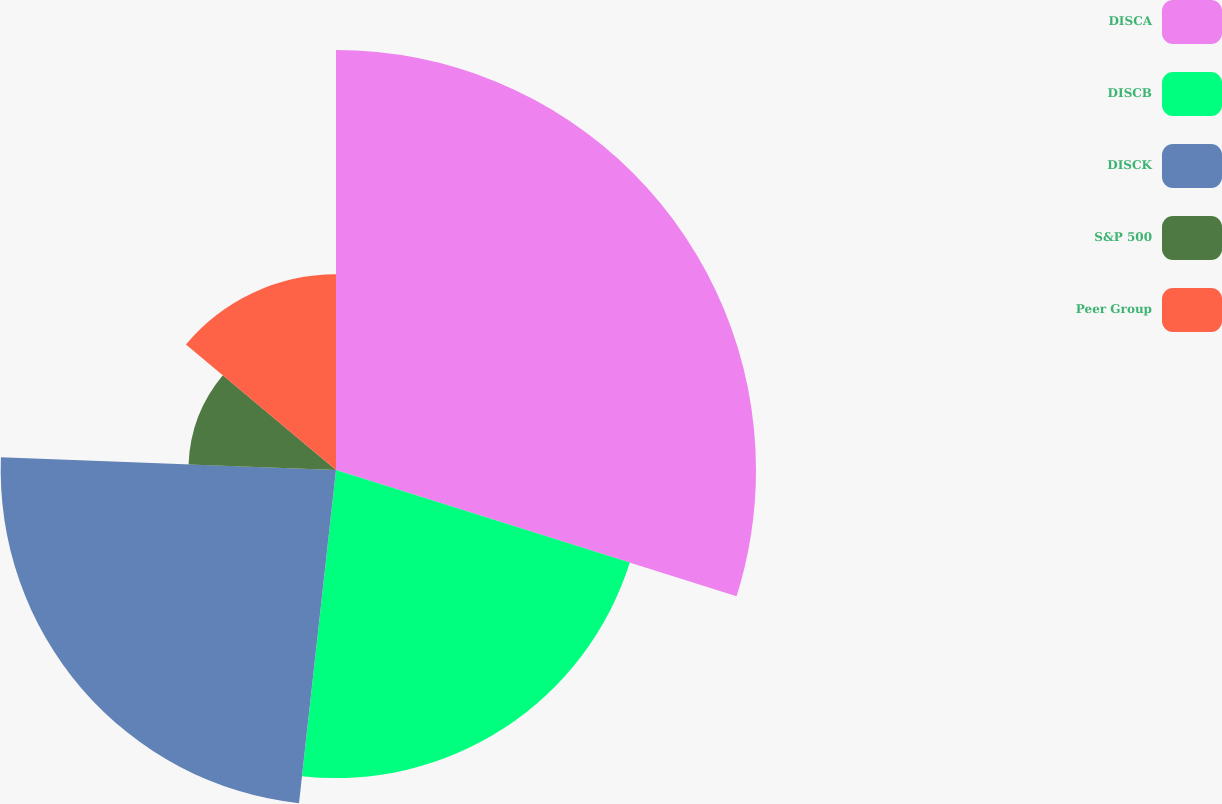<chart> <loc_0><loc_0><loc_500><loc_500><pie_chart><fcel>DISCA<fcel>DISCB<fcel>DISCK<fcel>S&P 500<fcel>Peer Group<nl><fcel>29.86%<fcel>21.9%<fcel>23.84%<fcel>10.49%<fcel>13.91%<nl></chart> 